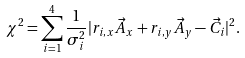<formula> <loc_0><loc_0><loc_500><loc_500>\chi ^ { 2 } = \sum _ { i = 1 } ^ { 4 } \frac { 1 } { \sigma _ { i } ^ { 2 } } | r _ { i , x } \vec { A } _ { x } + r _ { i , y } \vec { A } _ { y } - \vec { C } _ { i } | ^ { 2 } .</formula> 